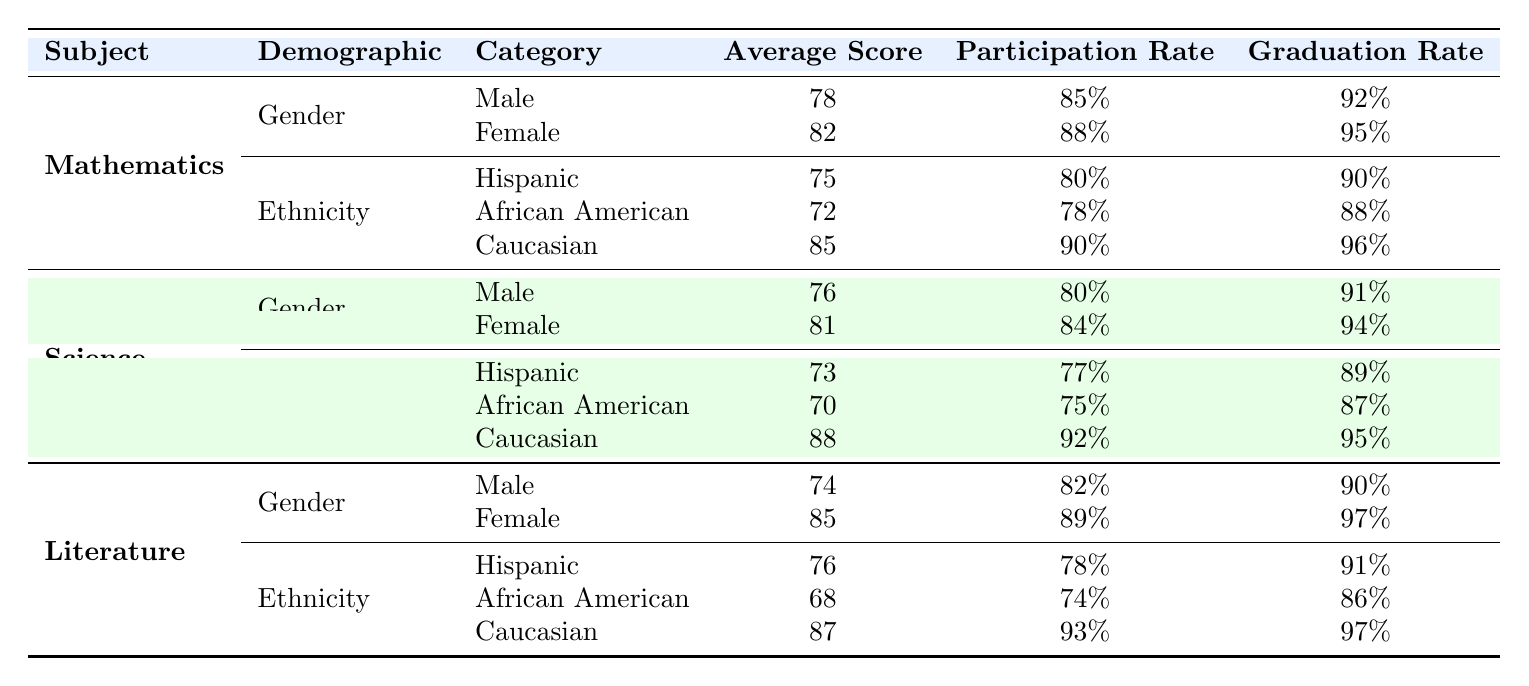What is the average score for female students in Mathematics? The table shows that the average score for female students in Mathematics is 82.
Answer: 82 What is the graduation rate for Caucasian students in Science? According to the table, the graduation rate for Caucasian students in Science is 95%.
Answer: 95% Do female students have a higher average score than male students in Literature? In Literature, the average score for female students is 85, while for male students it is 74. Since 85 is greater than 74, the statement is true.
Answer: Yes What is the average participation rate for Male students across all subjects? For Mathematics, Male participation rate is 85%, in Science it is 80%, and in Literature it is 82%. To find the average: (85 + 80 + 82) / 3 = 82.33%.
Answer: 82.33% Is the participation rate for Hispanic students in Mathematics greater than that for African American students in Science? The participation rate for Hispanic students in Mathematics is 80%, while for African American students in Science it is 75%. Since 80 is greater than 75, the answer is true.
Answer: Yes What is the sum of the graduation rates for Female students in all subjects? The graduation rates for Female students are 95% in Mathematics, 94% in Science, and 97% in Literature. Summing these: 95 + 94 + 97 = 286%.
Answer: 286 Which demographic group has the highest average score in Mathematics? By comparing the average scores in Mathematics, Caucasian students have the highest average score at 85, compared to 75 for Hispanic and 72 for African American students.
Answer: Caucasian What is the difference in average scores between Male and Female students in Science? The average score for Male students in Science is 76, and for Female students, it is 81. The difference is calculated as 81 - 76 = 5.
Answer: 5 What percentage of Hispanic students in Literature graduated? The table states that graduation rate for Hispanic students in Literature is 91%.
Answer: 91% 